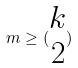<formula> <loc_0><loc_0><loc_500><loc_500>m \geq ( \begin{matrix} k \\ 2 \end{matrix} )</formula> 